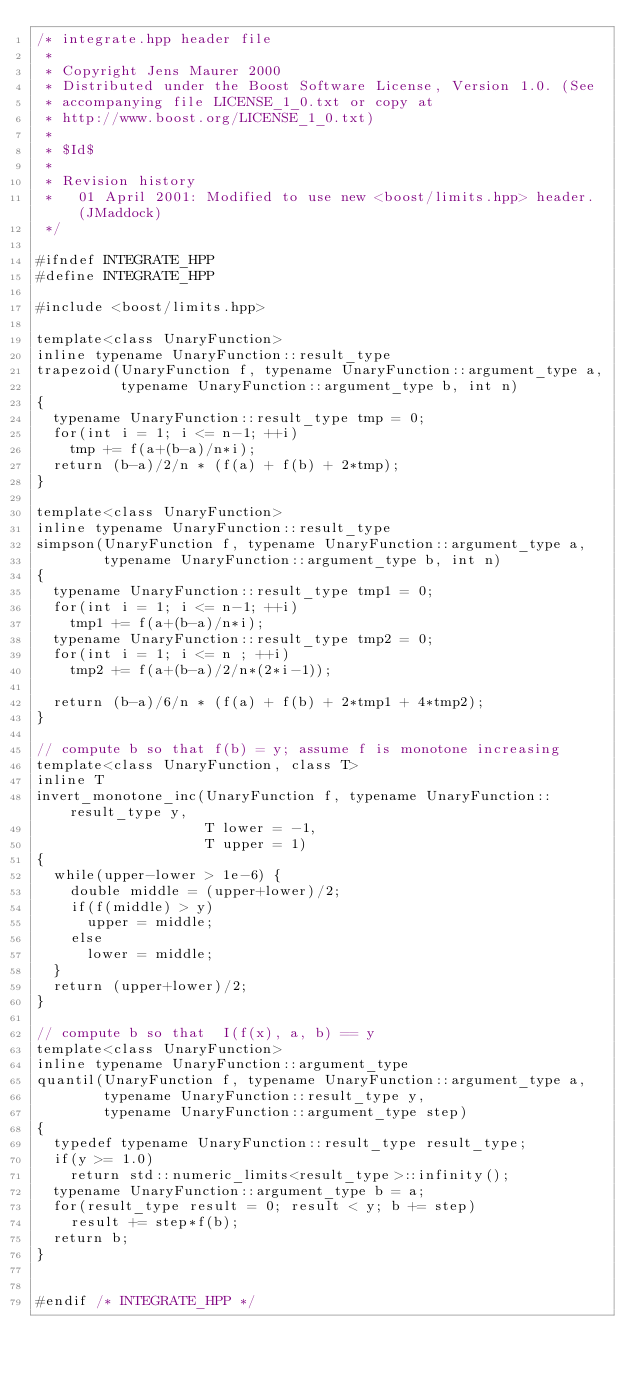<code> <loc_0><loc_0><loc_500><loc_500><_C++_>/* integrate.hpp header file
 *
 * Copyright Jens Maurer 2000
 * Distributed under the Boost Software License, Version 1.0. (See
 * accompanying file LICENSE_1_0.txt or copy at
 * http://www.boost.org/LICENSE_1_0.txt)
 *
 * $Id$
 *
 * Revision history
 *   01 April 2001: Modified to use new <boost/limits.hpp> header. (JMaddock)
 */

#ifndef INTEGRATE_HPP
#define INTEGRATE_HPP

#include <boost/limits.hpp>

template<class UnaryFunction>
inline typename UnaryFunction::result_type 
trapezoid(UnaryFunction f, typename UnaryFunction::argument_type a,
          typename UnaryFunction::argument_type b, int n)
{
  typename UnaryFunction::result_type tmp = 0;
  for(int i = 1; i <= n-1; ++i)
    tmp += f(a+(b-a)/n*i);
  return (b-a)/2/n * (f(a) + f(b) + 2*tmp);
}

template<class UnaryFunction>
inline typename UnaryFunction::result_type 
simpson(UnaryFunction f, typename UnaryFunction::argument_type a,
        typename UnaryFunction::argument_type b, int n)
{
  typename UnaryFunction::result_type tmp1 = 0;
  for(int i = 1; i <= n-1; ++i)
    tmp1 += f(a+(b-a)/n*i);
  typename UnaryFunction::result_type tmp2 = 0;
  for(int i = 1; i <= n ; ++i)
    tmp2 += f(a+(b-a)/2/n*(2*i-1));

  return (b-a)/6/n * (f(a) + f(b) + 2*tmp1 + 4*tmp2);
}

// compute b so that f(b) = y; assume f is monotone increasing
template<class UnaryFunction, class T>
inline T
invert_monotone_inc(UnaryFunction f, typename UnaryFunction::result_type y,
                    T lower = -1,
                    T upper = 1)
{
  while(upper-lower > 1e-6) {
    double middle = (upper+lower)/2;
    if(f(middle) > y)
      upper = middle;
    else
      lower = middle;
  }
  return (upper+lower)/2;
}

// compute b so that  I(f(x), a, b) == y
template<class UnaryFunction>
inline typename UnaryFunction::argument_type
quantil(UnaryFunction f, typename UnaryFunction::argument_type a,
        typename UnaryFunction::result_type y,
        typename UnaryFunction::argument_type step)
{
  typedef typename UnaryFunction::result_type result_type;
  if(y >= 1.0)
    return std::numeric_limits<result_type>::infinity();
  typename UnaryFunction::argument_type b = a;
  for(result_type result = 0; result < y; b += step)
    result += step*f(b);
  return b;
}


#endif /* INTEGRATE_HPP */
</code> 